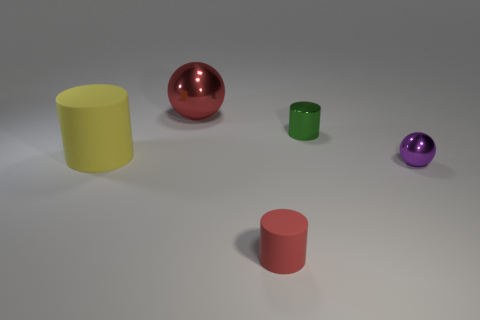Add 4 red objects. How many objects exist? 9 Subtract all cylinders. How many objects are left? 2 Add 1 red matte objects. How many red matte objects are left? 2 Add 4 brown metallic things. How many brown metallic things exist? 4 Subtract 0 green blocks. How many objects are left? 5 Subtract all large cyan rubber blocks. Subtract all small purple shiny objects. How many objects are left? 4 